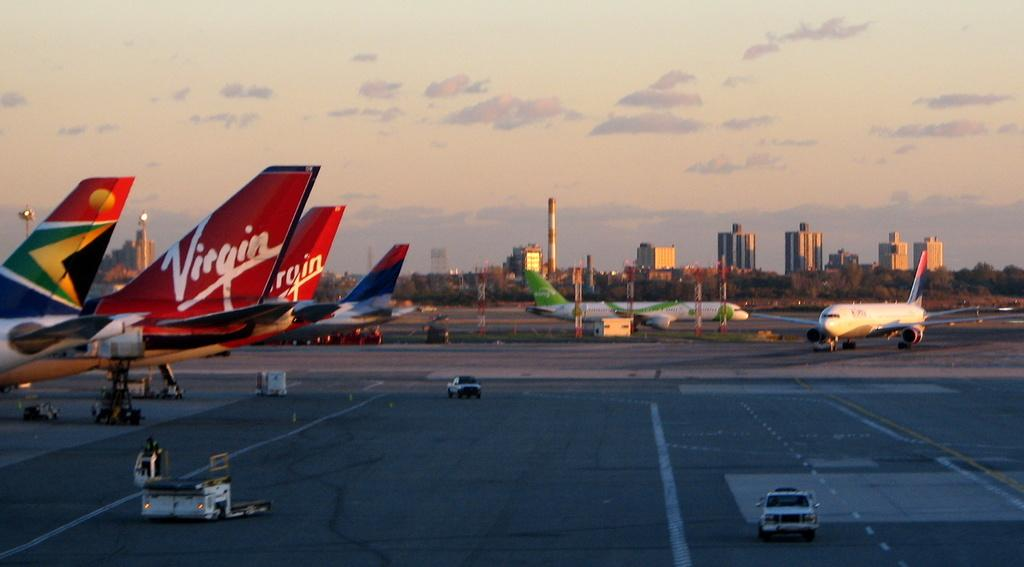<image>
Present a compact description of the photo's key features. Two Virgin Airline airplanes sit on the tarmac at the airport. 